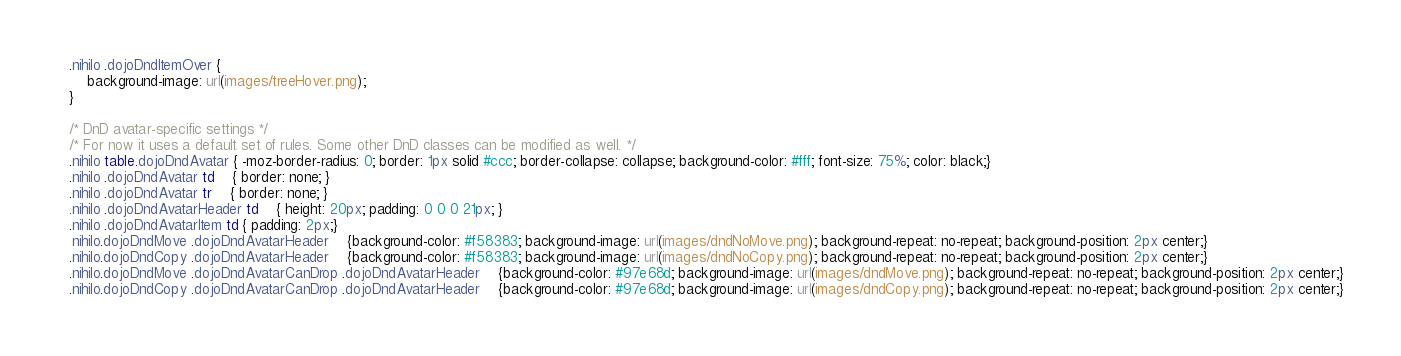<code> <loc_0><loc_0><loc_500><loc_500><_CSS_>.nihilo .dojoDndItemOver {
	background-image: url(images/treeHover.png);
}

/* DnD avatar-specific settings */
/* For now it uses a default set of rules. Some other DnD classes can be modified as well. */
.nihilo table.dojoDndAvatar { -moz-border-radius: 0; border: 1px solid #ccc; border-collapse: collapse; background-color: #fff; font-size: 75%; color: black;}
.nihilo .dojoDndAvatar td	{ border: none; }
.nihilo .dojoDndAvatar tr	{ border: none; }
.nihilo .dojoDndAvatarHeader td	{ height: 20px; padding: 0 0 0 21px; }
.nihilo .dojoDndAvatarItem td { padding: 2px;}
.nihilo.dojoDndMove .dojoDndAvatarHeader	{background-color: #f58383; background-image: url(images/dndNoMove.png); background-repeat: no-repeat; background-position: 2px center;}
.nihilo.dojoDndCopy .dojoDndAvatarHeader	{background-color: #f58383; background-image: url(images/dndNoCopy.png); background-repeat: no-repeat; background-position: 2px center;}
.nihilo.dojoDndMove .dojoDndAvatarCanDrop .dojoDndAvatarHeader	{background-color: #97e68d; background-image: url(images/dndMove.png); background-repeat: no-repeat; background-position: 2px center;}
.nihilo.dojoDndCopy .dojoDndAvatarCanDrop .dojoDndAvatarHeader	{background-color: #97e68d; background-image: url(images/dndCopy.png); background-repeat: no-repeat; background-position: 2px center;}
</code> 